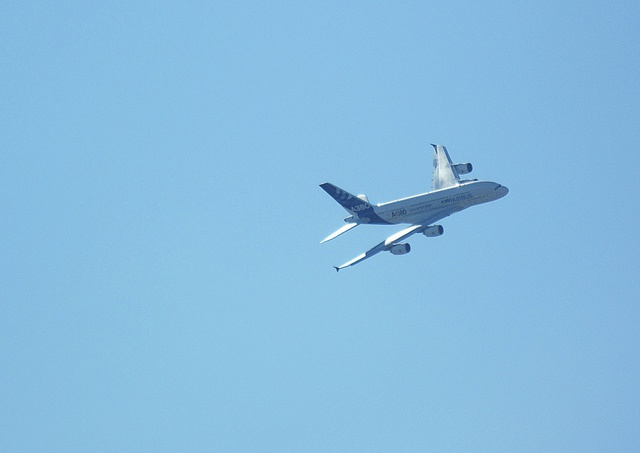Describe the objects in this image and their specific colors. I can see a airplane in lightblue, gray, blue, and white tones in this image. 